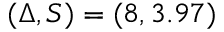Convert formula to latex. <formula><loc_0><loc_0><loc_500><loc_500>( \Delta , S ) = ( 8 , 3 . 9 7 )</formula> 